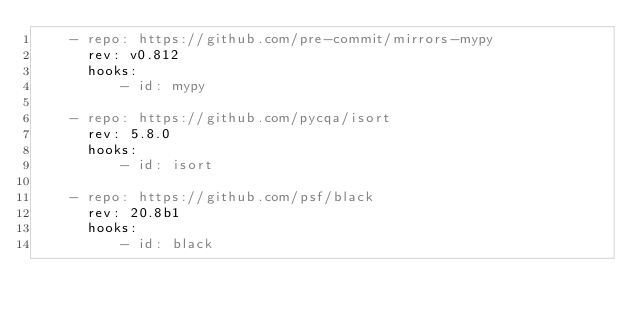Convert code to text. <code><loc_0><loc_0><loc_500><loc_500><_YAML_>    - repo: https://github.com/pre-commit/mirrors-mypy
      rev: v0.812
      hooks:
          - id: mypy

    - repo: https://github.com/pycqa/isort
      rev: 5.8.0
      hooks:
          - id: isort

    - repo: https://github.com/psf/black
      rev: 20.8b1
      hooks:
          - id: black
</code> 